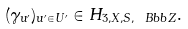Convert formula to latex. <formula><loc_0><loc_0><loc_500><loc_500>( \gamma _ { u ^ { \prime } } ) _ { u ^ { \prime } \in U ^ { \prime } } \in H _ { 3 , X , S , \ B b b { Z } } .</formula> 